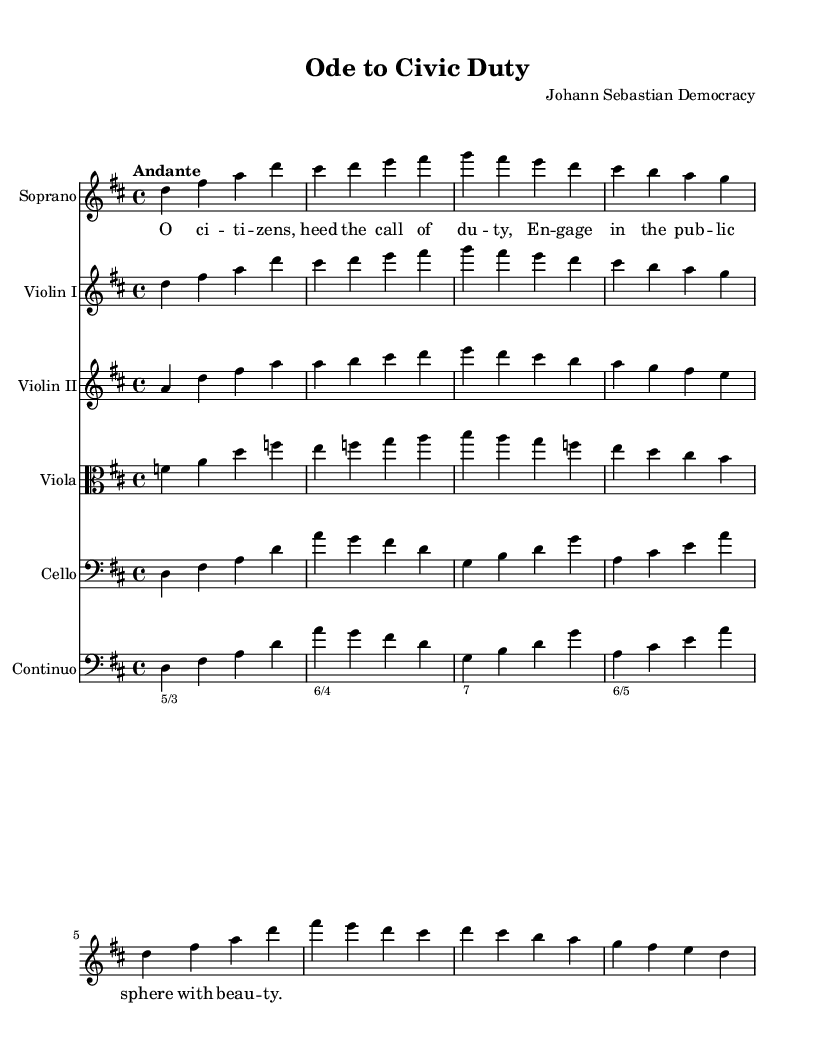What is the key signature of this music? The key signature is D major, which has two sharps (F# and C#). This can be determined by looking at the key signature at the beginning of the score.
Answer: D major What is the time signature of the piece? The time signature is 4/4, which indicates there are four beats in each measure and a quarter note receives one beat. This is clearly indicated at the beginning of the score.
Answer: 4/4 What is the tempo marking for the piece? The tempo marking is "Andante," indicating a moderately slow tempo. This marking is provided at the beginning of the score.
Answer: Andante Which instrument has the higher melodic line in the introduction? The Soprano has the higher melodic line in the introduction. This can be observed by looking at the pitches and their notation in the score, where Soprano notes are higher than other instrumental parts.
Answer: Soprano How many instruments are included in the score? There are six instruments included in the score: Soprano, Violin I, Violin II, Viola, Cello, and Continuo. This can be counted by reviewing the parts listed in the score.
Answer: Six What is the title of the composition? The title of the composition is "Ode to Civic Duty." This is stated at the top of the score under the header section.
Answer: Ode to Civic Duty Is the piece in major or minor tonality? The piece is in major tonality, specifically D major. This can be concluded from the key signature and the overall bright character of the melodies presented in the score.
Answer: Major 